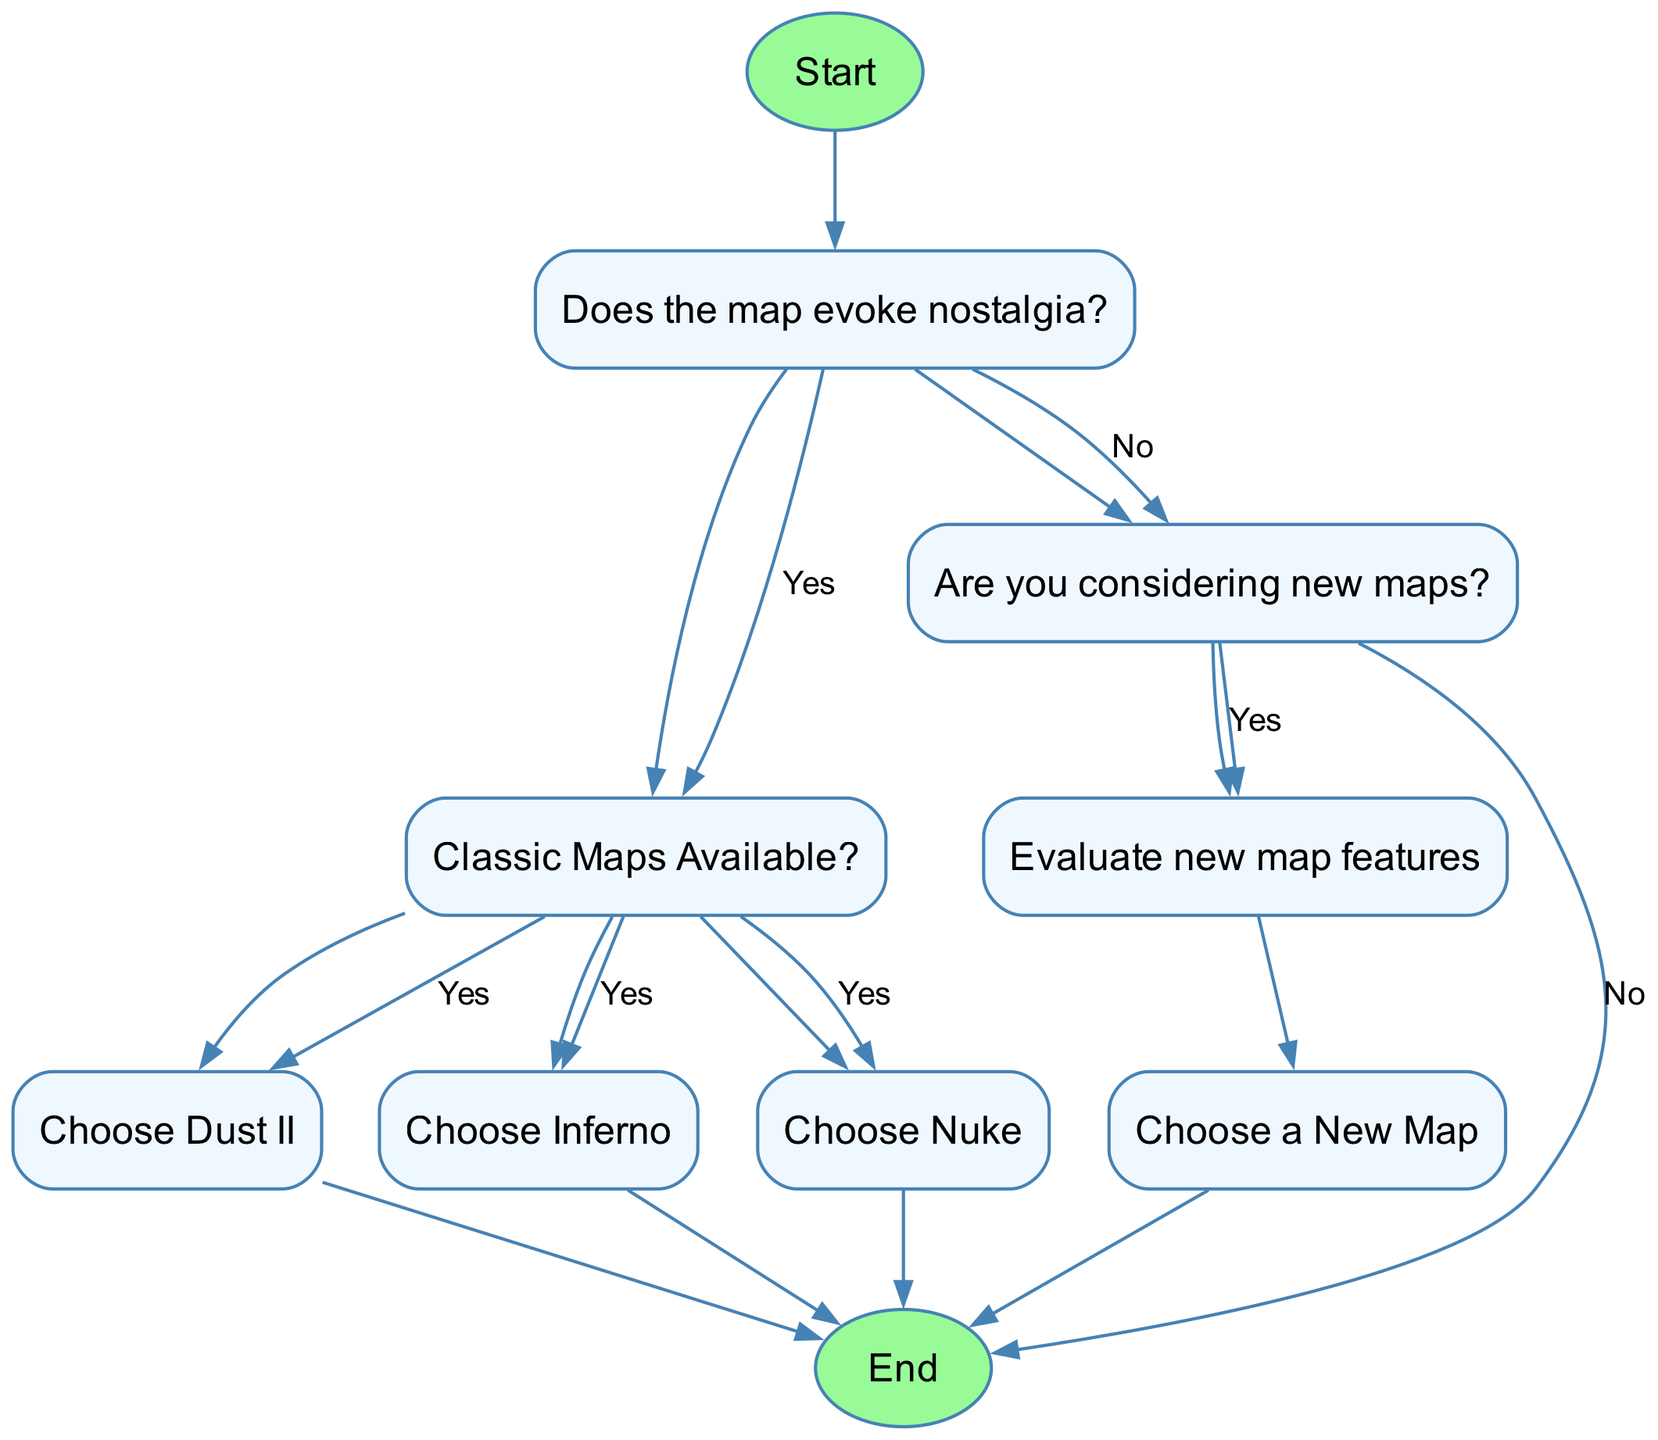What is the first step in the decision process? The first step is labeled "Start," which begins the flow chart process.
Answer: Start How many classic maps are presented in the flow chart? The classic maps available in the chart are Dust II, Inferno, and Nuke, which totals three options.
Answer: Three What happens if nostalgia is not evoked by the map? If nostalgia is not evoked, the flow proceeds to the node asking if new maps are considered, indicating the option to select new maps rather than classic ones.
Answer: Proceed to new maps Which classic map is chosen after confirming the availability of classic maps? After confirming classic maps are available, the flow offers options to choose from Dust II, Inferno, or Nuke, reflecting popular classic maps in the game.
Answer: Dust II, Inferno, Nuke What is the next action after deciding to evaluate new map features? The next action after evaluating new map features is to choose a new map, indicating a decision point to select from newly available maps.
Answer: Choose a New Map What is the relationship between the nodes "new_maps" and "end"? The "new_maps" node has a direct edge leading to "end" labeled "No," indicating that if new maps are not considered, the process ends there rather than choosing a map.
Answer: Direct edge to end What would happen if classic maps are not available? If classic maps are not available, the flow moves to the "new_maps" node, suggesting the decision to consider new maps instead.
Answer: Move to new maps How many nodes are there in total in the diagram? The diagram consists of nine distinct nodes, including the start and end nodes, capturing all decision points and outcomes.
Answer: Nine 